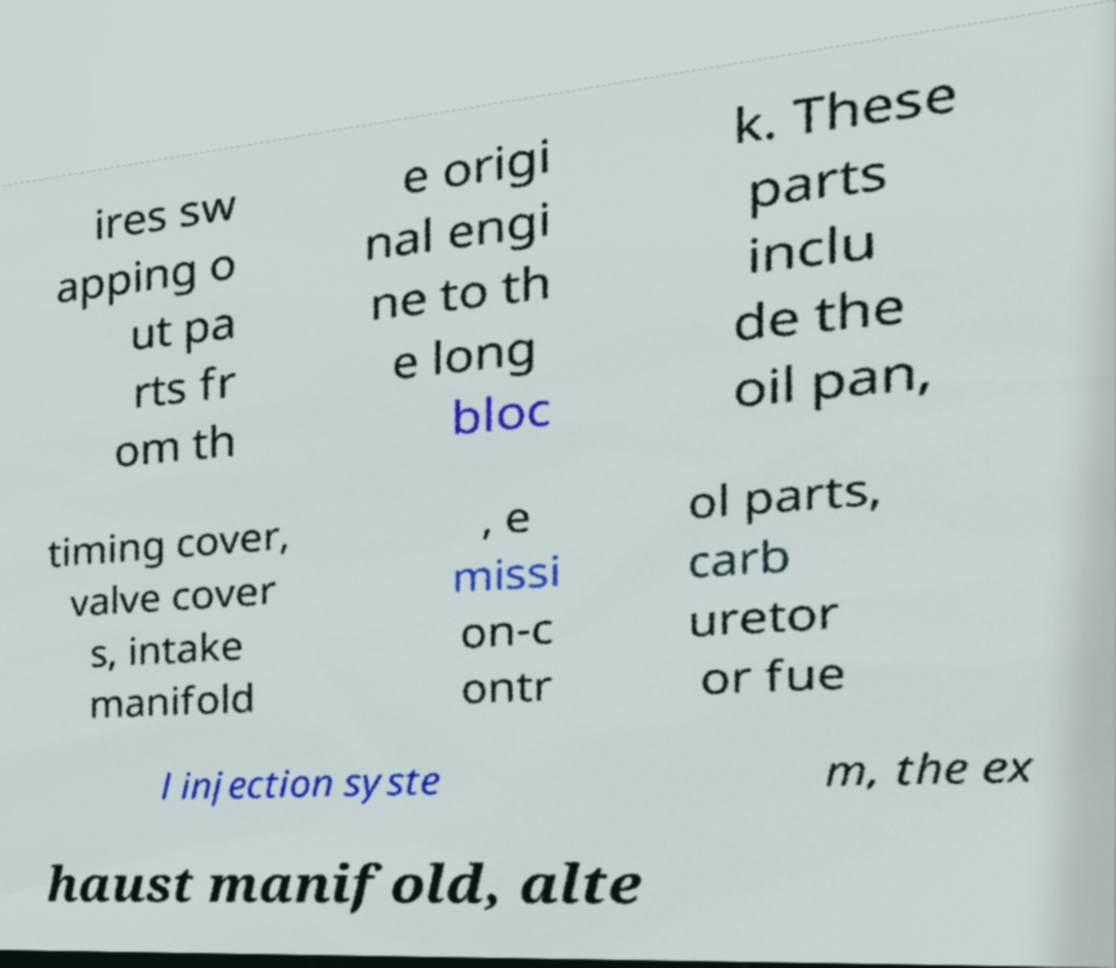Please read and relay the text visible in this image. What does it say? ires sw apping o ut pa rts fr om th e origi nal engi ne to th e long bloc k. These parts inclu de the oil pan, timing cover, valve cover s, intake manifold , e missi on-c ontr ol parts, carb uretor or fue l injection syste m, the ex haust manifold, alte 